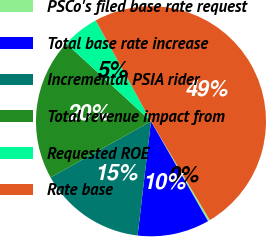Convert chart. <chart><loc_0><loc_0><loc_500><loc_500><pie_chart><fcel>PSCo's filed base rate request<fcel>Total base rate increase<fcel>Incremental PSIA rider<fcel>Total revenue impact from<fcel>Requested ROE<fcel>Rate base<nl><fcel>0.29%<fcel>10.11%<fcel>15.03%<fcel>19.94%<fcel>5.2%<fcel>49.43%<nl></chart> 